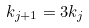<formula> <loc_0><loc_0><loc_500><loc_500>k _ { j + 1 } = 3 k _ { j }</formula> 